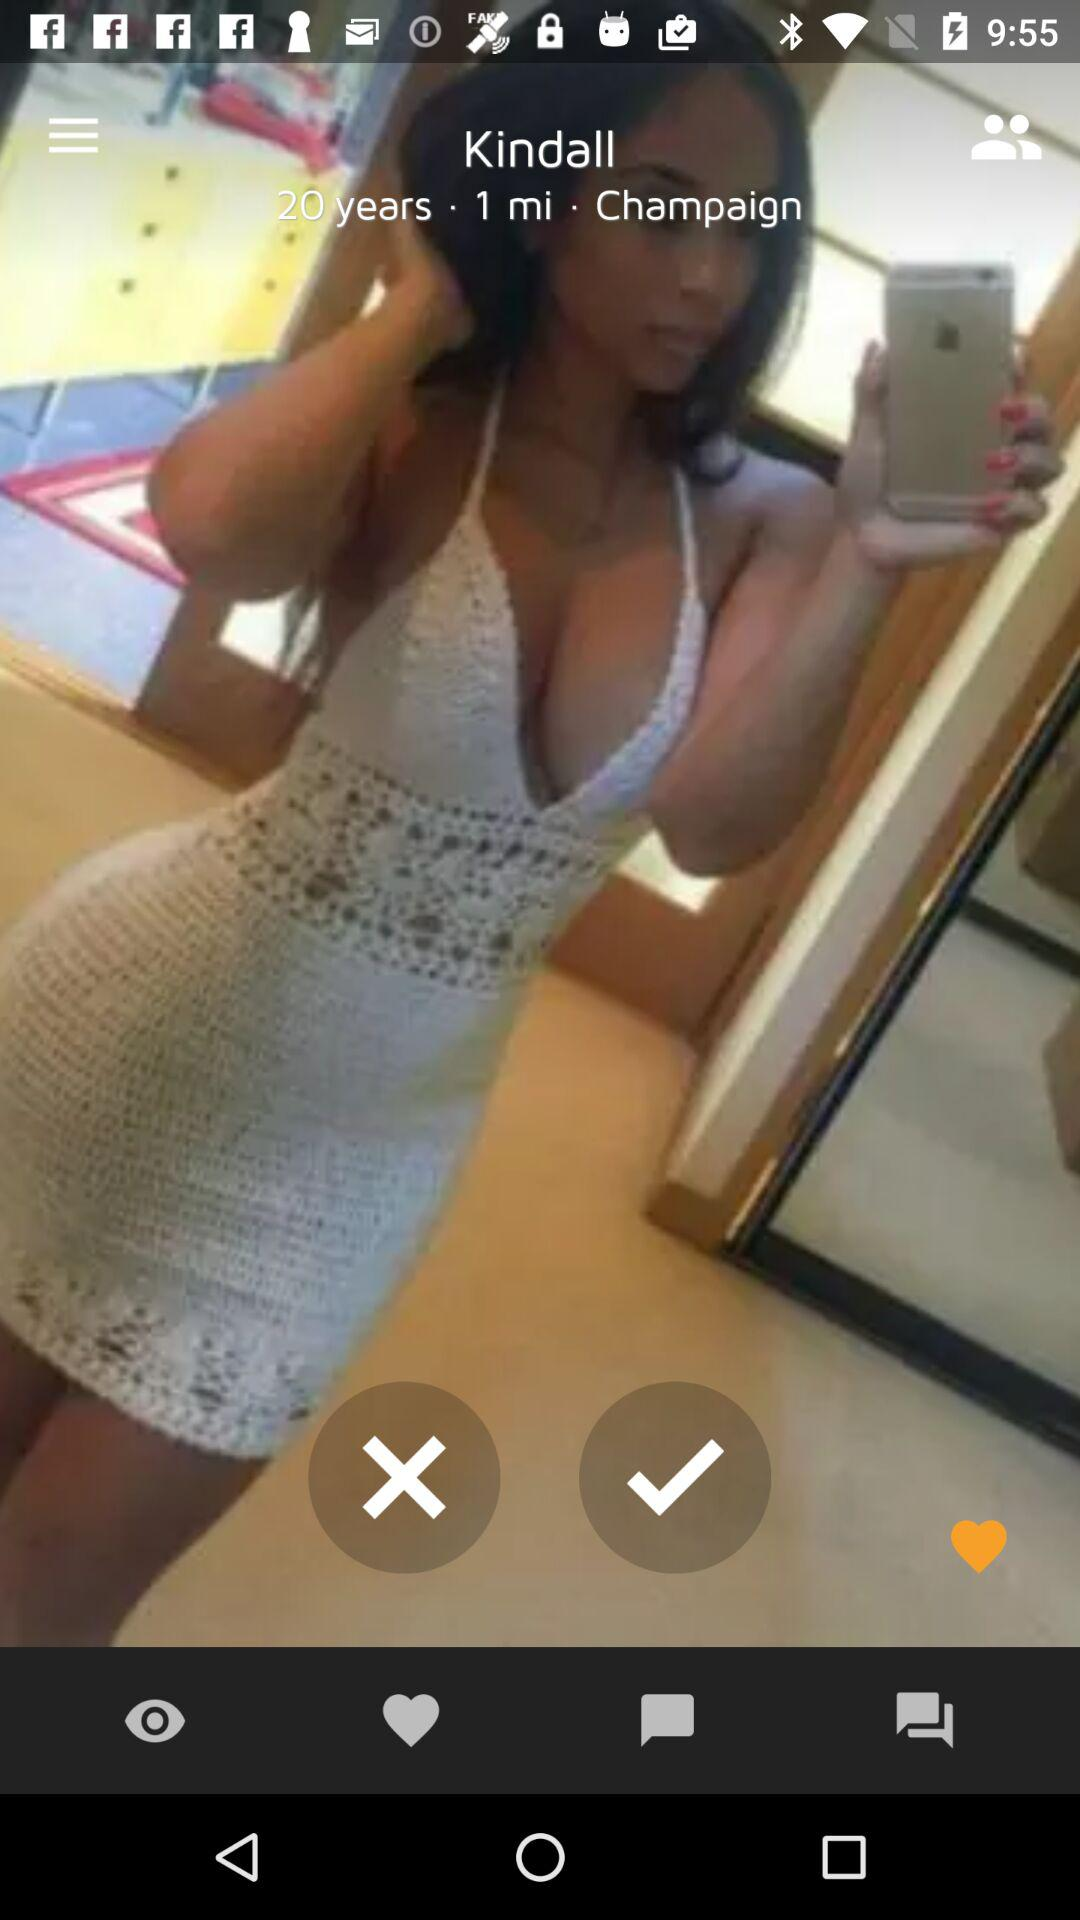What is the mentioned location? The mentioned location is Champaign. 